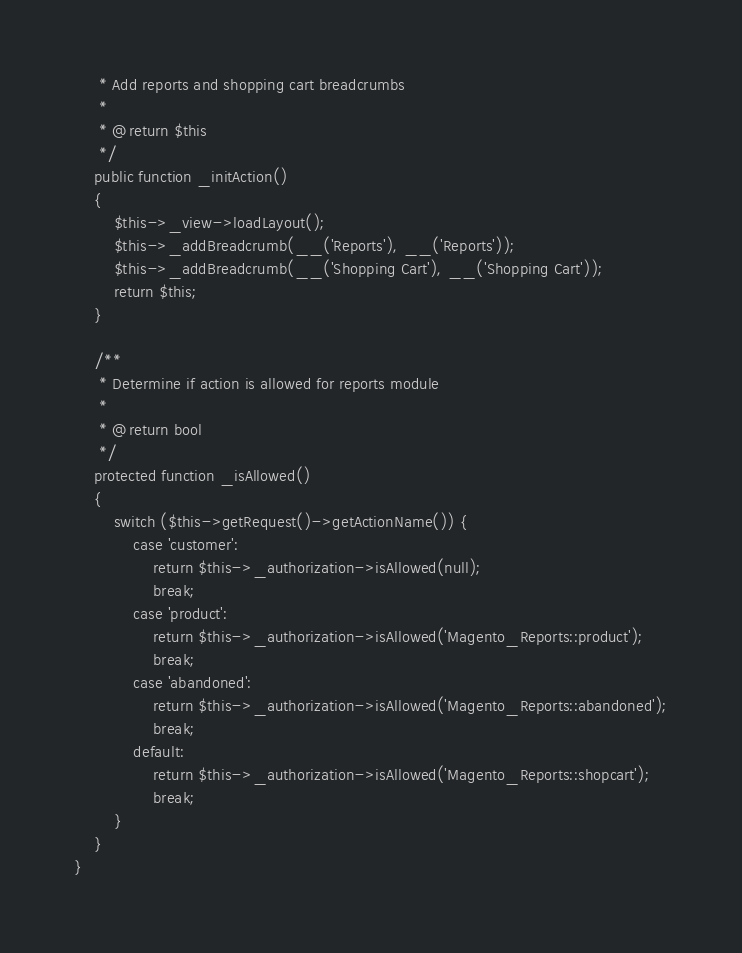<code> <loc_0><loc_0><loc_500><loc_500><_PHP_>     * Add reports and shopping cart breadcrumbs
     *
     * @return $this
     */
    public function _initAction()
    {
        $this->_view->loadLayout();
        $this->_addBreadcrumb(__('Reports'), __('Reports'));
        $this->_addBreadcrumb(__('Shopping Cart'), __('Shopping Cart'));
        return $this;
    }

    /**
     * Determine if action is allowed for reports module
     *
     * @return bool
     */
    protected function _isAllowed()
    {
        switch ($this->getRequest()->getActionName()) {
            case 'customer':
                return $this->_authorization->isAllowed(null);
                break;
            case 'product':
                return $this->_authorization->isAllowed('Magento_Reports::product');
                break;
            case 'abandoned':
                return $this->_authorization->isAllowed('Magento_Reports::abandoned');
                break;
            default:
                return $this->_authorization->isAllowed('Magento_Reports::shopcart');
                break;
        }
    }
}
</code> 